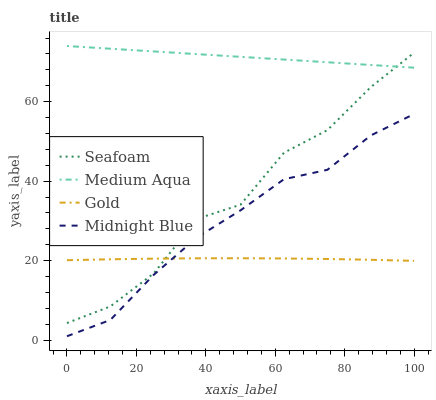Does Gold have the minimum area under the curve?
Answer yes or no. Yes. Does Medium Aqua have the maximum area under the curve?
Answer yes or no. Yes. Does Seafoam have the minimum area under the curve?
Answer yes or no. No. Does Seafoam have the maximum area under the curve?
Answer yes or no. No. Is Medium Aqua the smoothest?
Answer yes or no. Yes. Is Seafoam the roughest?
Answer yes or no. Yes. Is Gold the smoothest?
Answer yes or no. No. Is Gold the roughest?
Answer yes or no. No. Does Midnight Blue have the lowest value?
Answer yes or no. Yes. Does Seafoam have the lowest value?
Answer yes or no. No. Does Medium Aqua have the highest value?
Answer yes or no. Yes. Does Seafoam have the highest value?
Answer yes or no. No. Is Midnight Blue less than Seafoam?
Answer yes or no. Yes. Is Medium Aqua greater than Midnight Blue?
Answer yes or no. Yes. Does Seafoam intersect Medium Aqua?
Answer yes or no. Yes. Is Seafoam less than Medium Aqua?
Answer yes or no. No. Is Seafoam greater than Medium Aqua?
Answer yes or no. No. Does Midnight Blue intersect Seafoam?
Answer yes or no. No. 